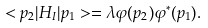Convert formula to latex. <formula><loc_0><loc_0><loc_500><loc_500>< { p } _ { 2 } | H _ { I } | { p } _ { 1 } > = \lambda \varphi ( { p } _ { 2 } ) \varphi ^ { * } ( { p } _ { 1 } ) .</formula> 